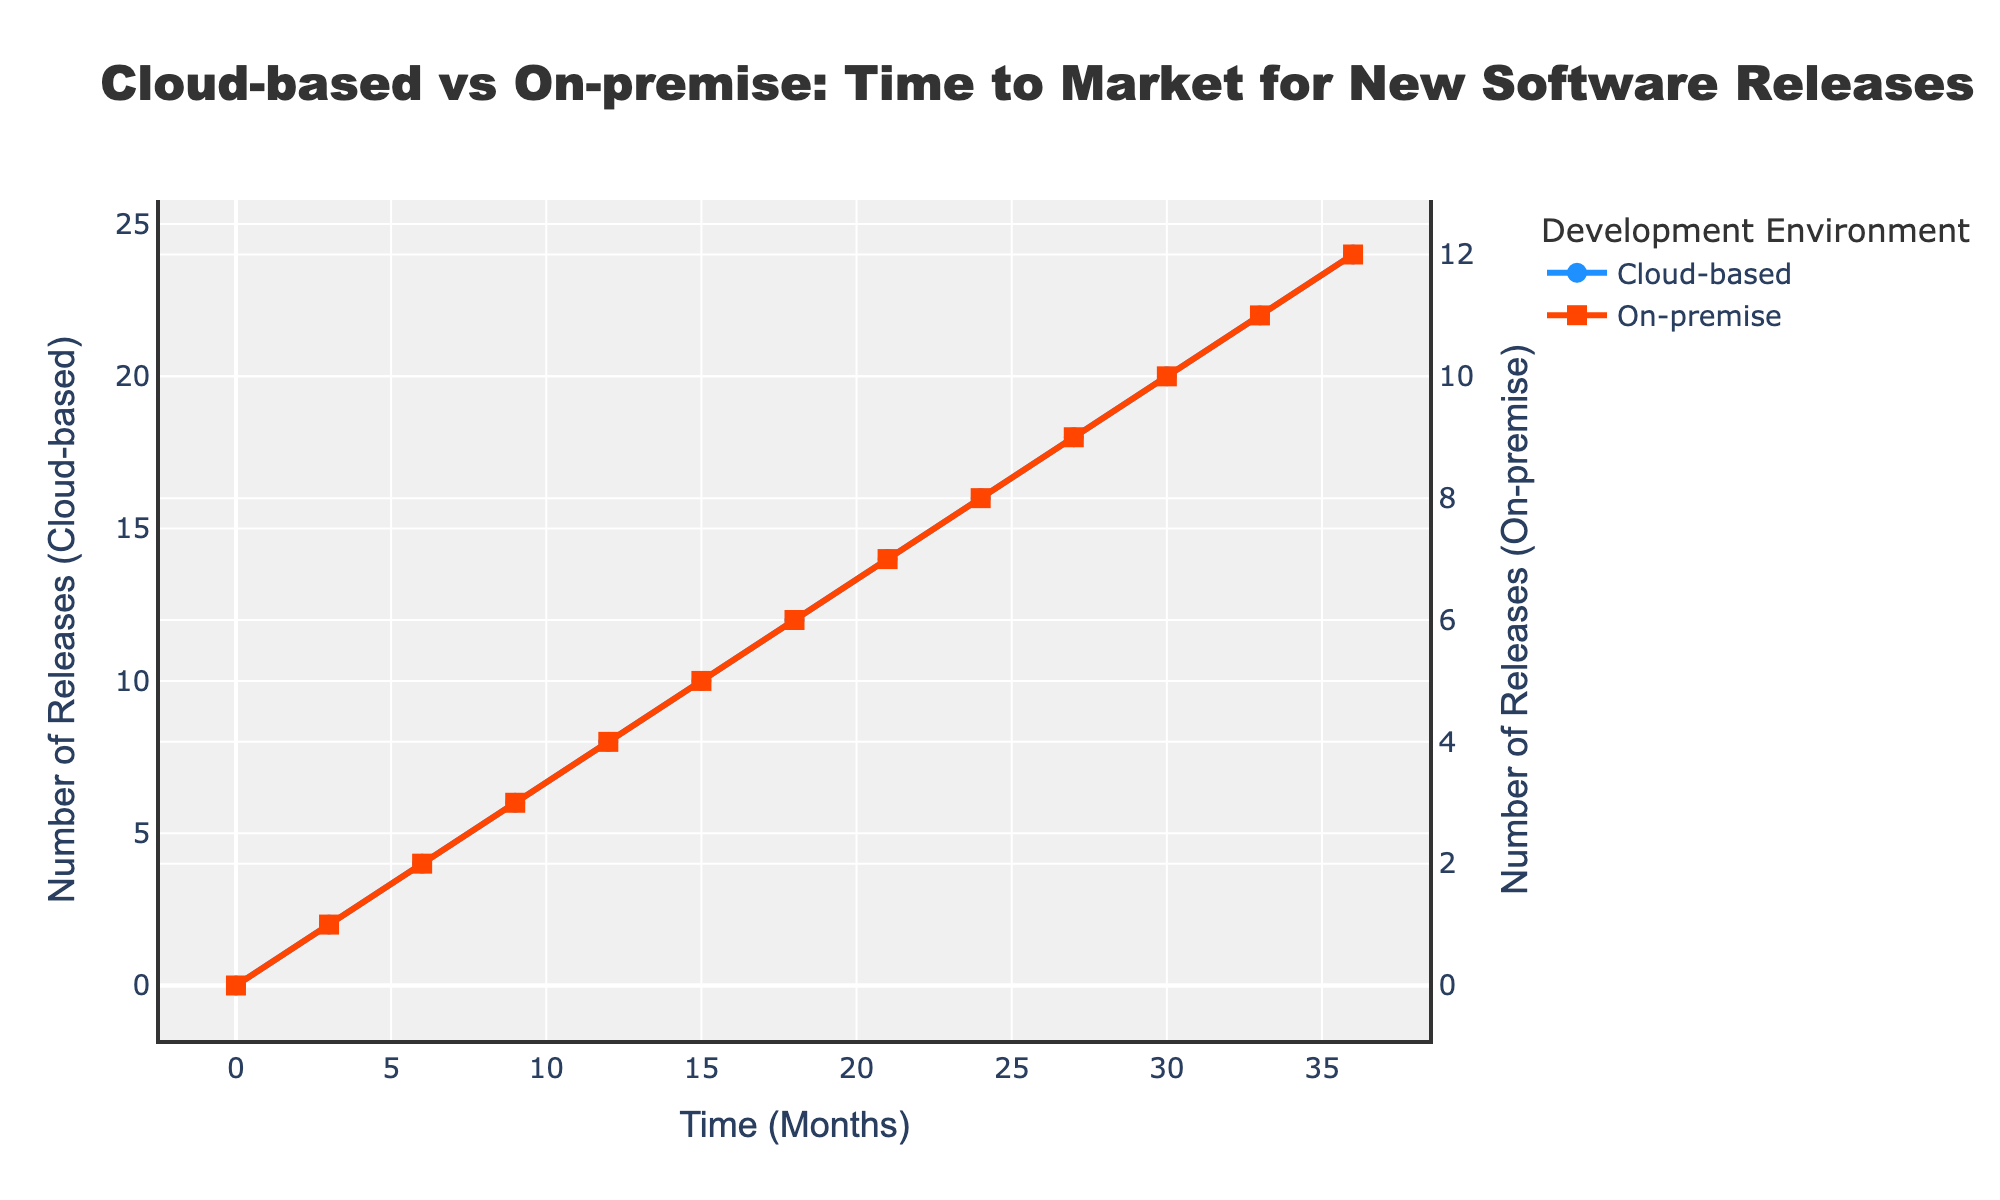Which development environment has a faster time to market at 18 months? By looking at the figure, the cloud-based development environment has 12 releases at 18 months, while the on-premise environment has only 6 releases at the same time. Therefore, the cloud-based environment has a faster time to market.
Answer: Cloud-based How many more releases does the cloud-based environment have compared to the on-premise environment at 36 months? The cloud-based environment has 24 releases at 36 months, and the on-premise environment has 12 releases. The difference is 24 - 12 = 12 releases.
Answer: 12 What is the average number of releases for the cloud-based environment between 0 to 36 months? Summing the releases at each interval for the cloud-based environment gives (0 + 2 + 4 + 6 + 8 + 10 + 12 + 14 + 16 + 18 + 20 + 22 + 24) = 156. There are 13 intervals, so the average is 156 / 13 which equals 12.
Answer: 12 Which line has a steeper slope, indicating a faster rate of increase in releases? Comparing the slopes visually, it is evident that the cloud-based environment's line is steeper than the on-premise environment’s line, indicating a faster rate of increase in releases over time.
Answer: Cloud-based At which month do both the cloud-based and on-premise environments have exactly double the number of releases compared to the other? Analyzing the figure, at 6 months, the cloud-based environment has 4 releases while the on-premise environment has 2 releases, exactly double the number of on-premise releases. Similarly, at 30 months, the cloud-based environment has 20 releases, double the on-premise's 10 releases.
Answer: 6 and 30 What is the difference between the number of releases for the two environments at 9 months? At 9 months, the cloud-based environment has 6 releases whereas the on-premise environment has 3 releases. The difference is 6 - 3 = 3 releases.
Answer: 3 How many months does it take for the cloud-based environment to reach 10 releases? By examining the line chart, the cloud-based environment reaches 10 releases at 15 months.
Answer: 15 Calculate the total number of releases for both environments at 24 months. The cloud-based environment has 16 releases at 24 months and the on-premise environment has 8 releases. Total releases = 16 + 8 = 24.
Answer: 24 